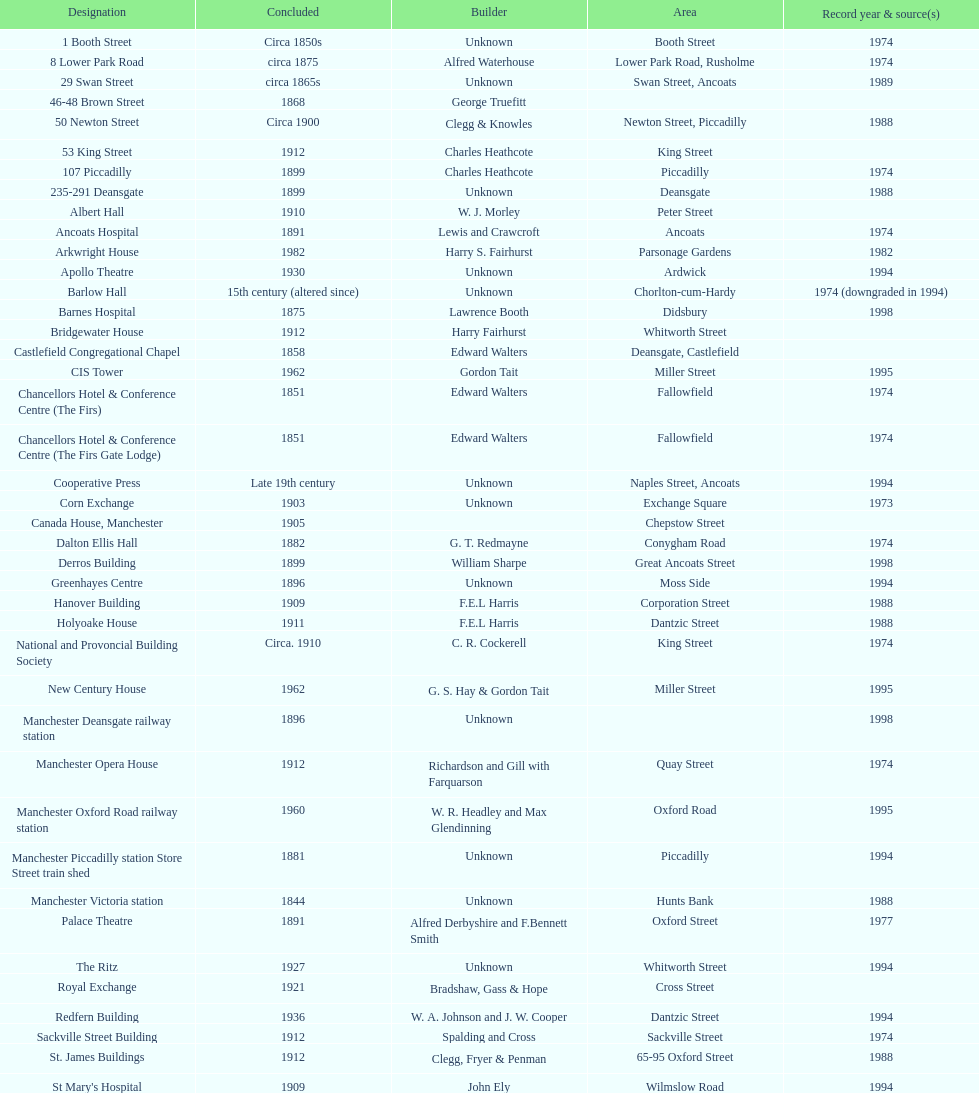How many buildings do not have an image listed? 11. 